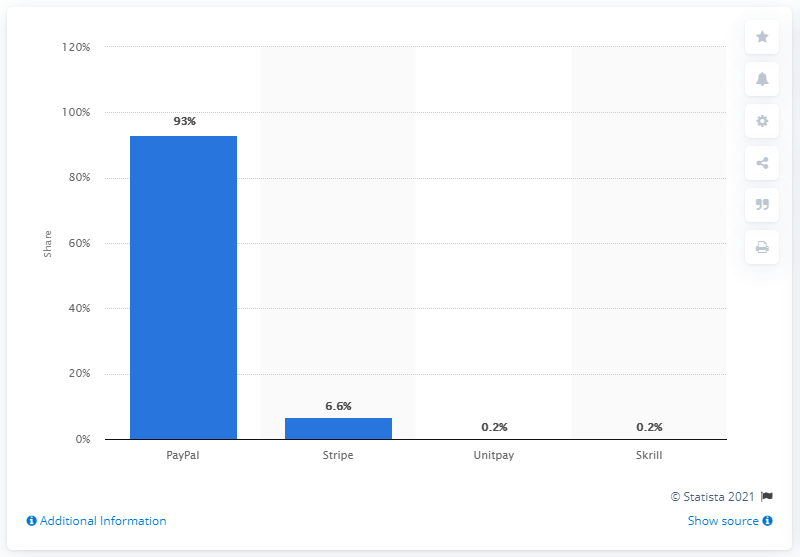Highlight a few significant elements in this photo. The payment method used to tip video streamers was PayPal. 